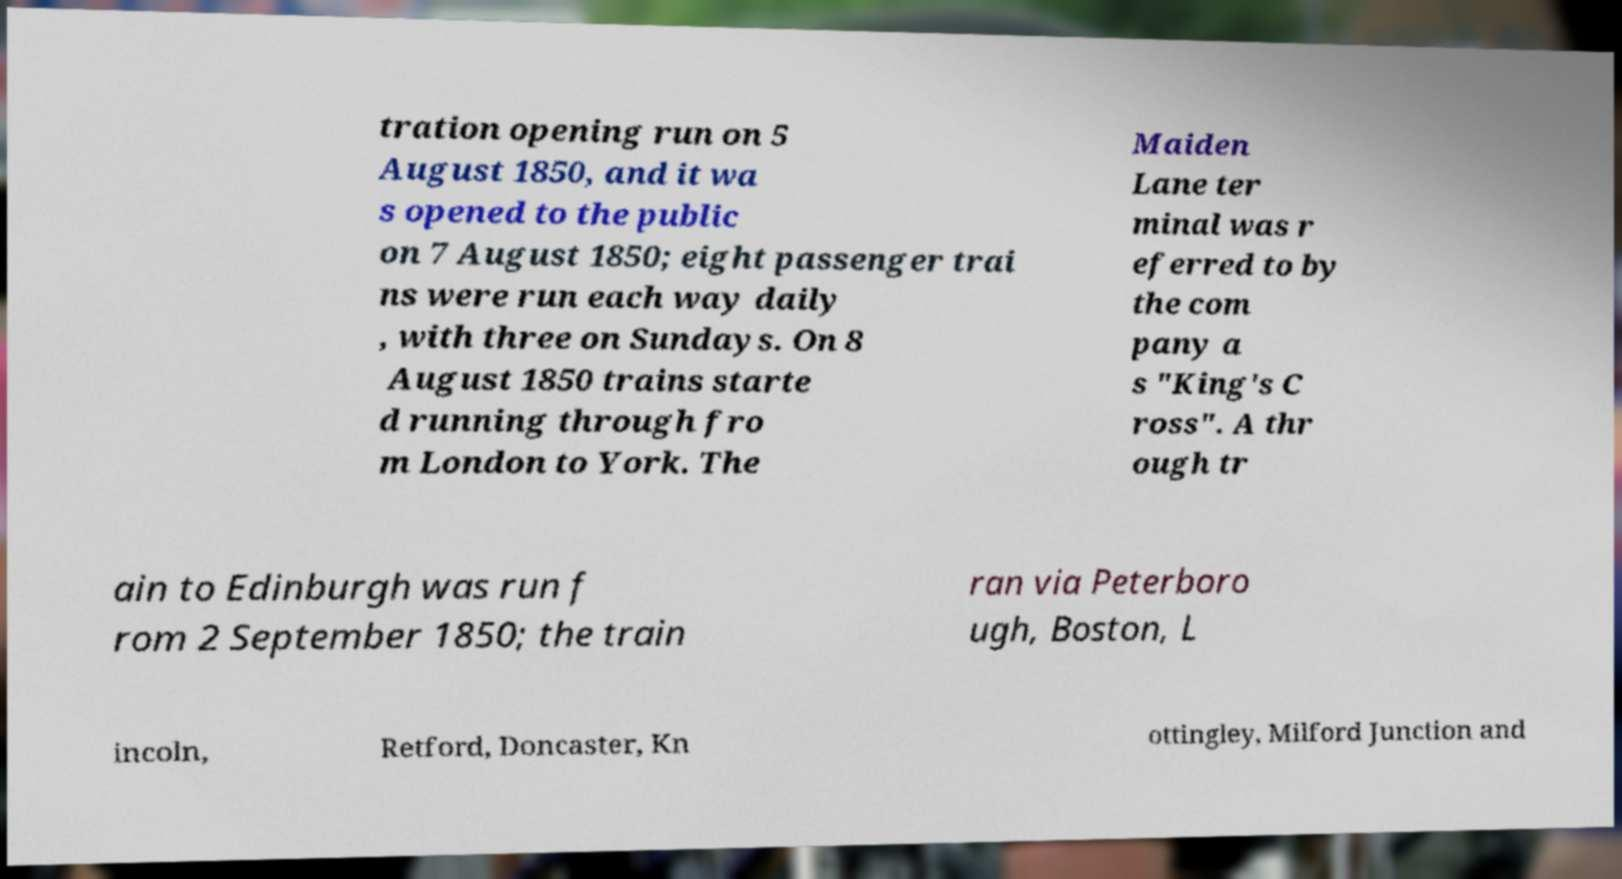Could you assist in decoding the text presented in this image and type it out clearly? tration opening run on 5 August 1850, and it wa s opened to the public on 7 August 1850; eight passenger trai ns were run each way daily , with three on Sundays. On 8 August 1850 trains starte d running through fro m London to York. The Maiden Lane ter minal was r eferred to by the com pany a s "King's C ross". A thr ough tr ain to Edinburgh was run f rom 2 September 1850; the train ran via Peterboro ugh, Boston, L incoln, Retford, Doncaster, Kn ottingley, Milford Junction and 